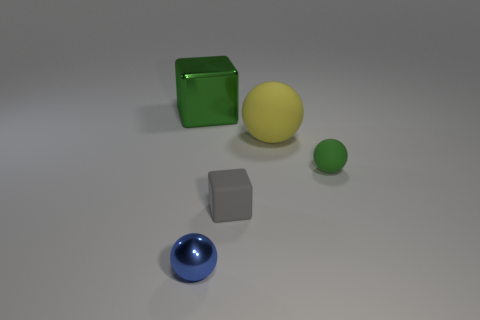How many other things are the same color as the tiny matte sphere?
Keep it short and to the point. 1. There is a thing that is the same color as the large metallic block; what is its size?
Provide a short and direct response. Small. Is there another yellow rubber ball of the same size as the yellow ball?
Your answer should be compact. No. What is the color of the large rubber object that is the same shape as the small blue thing?
Your answer should be very brief. Yellow. There is a block that is in front of the large shiny thing; is there a big object that is left of it?
Offer a terse response. Yes. Is the shape of the object that is left of the metallic sphere the same as  the small gray thing?
Your answer should be very brief. Yes. What is the shape of the gray object?
Provide a short and direct response. Cube. What number of other small blue spheres have the same material as the blue sphere?
Ensure brevity in your answer.  0. Is the color of the small matte block the same as the small object to the right of the rubber cube?
Keep it short and to the point. No. How many tiny blue things are there?
Your response must be concise. 1. 